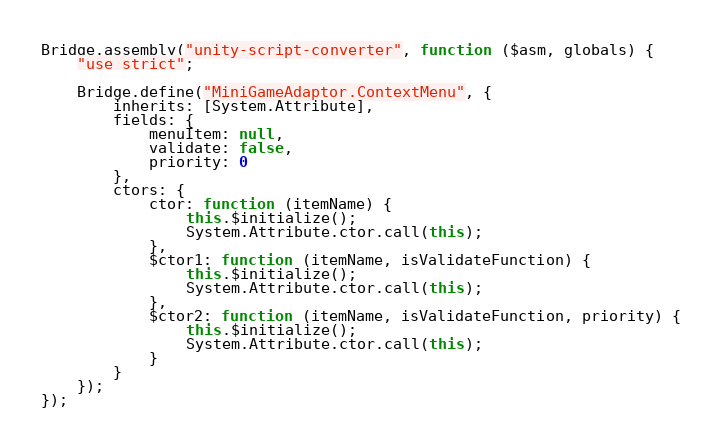Convert code to text. <code><loc_0><loc_0><loc_500><loc_500><_JavaScript_>Bridge.assembly("unity-script-converter", function ($asm, globals) {
    "use strict";

    Bridge.define("MiniGameAdaptor.ContextMenu", {
        inherits: [System.Attribute],
        fields: {
            menuItem: null,
            validate: false,
            priority: 0
        },
        ctors: {
            ctor: function (itemName) {
                this.$initialize();
                System.Attribute.ctor.call(this);
            },
            $ctor1: function (itemName, isValidateFunction) {
                this.$initialize();
                System.Attribute.ctor.call(this);
            },
            $ctor2: function (itemName, isValidateFunction, priority) {
                this.$initialize();
                System.Attribute.ctor.call(this);
            }
        }
    });
});
</code> 